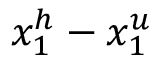Convert formula to latex. <formula><loc_0><loc_0><loc_500><loc_500>x _ { 1 } ^ { h } - x _ { 1 } ^ { u }</formula> 